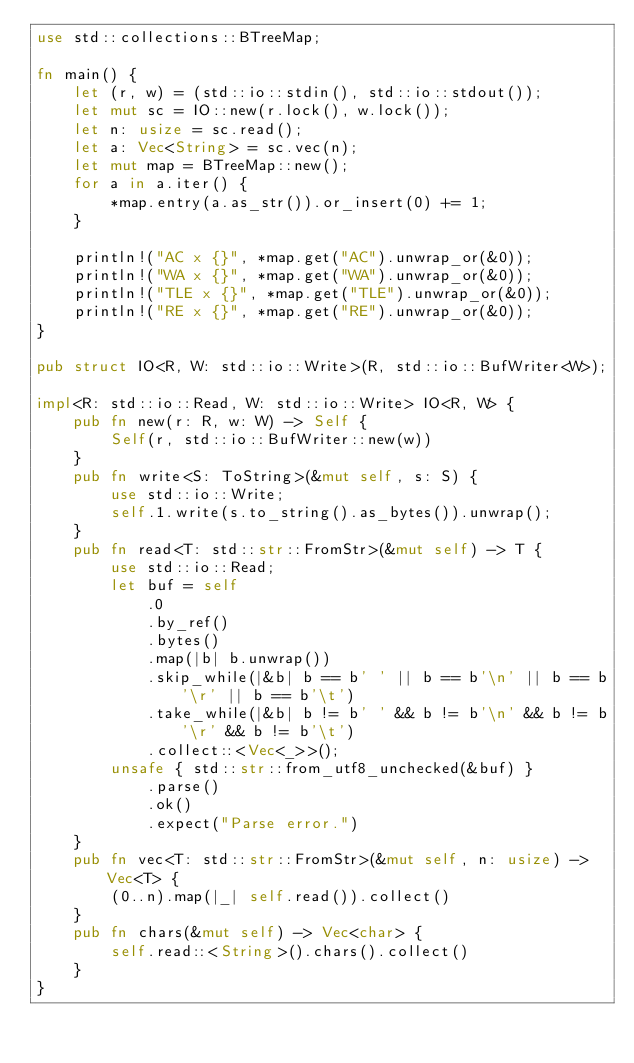<code> <loc_0><loc_0><loc_500><loc_500><_Rust_>use std::collections::BTreeMap;

fn main() {
    let (r, w) = (std::io::stdin(), std::io::stdout());
    let mut sc = IO::new(r.lock(), w.lock());
    let n: usize = sc.read();
    let a: Vec<String> = sc.vec(n);
    let mut map = BTreeMap::new();
    for a in a.iter() {
        *map.entry(a.as_str()).or_insert(0) += 1;
    }

    println!("AC x {}", *map.get("AC").unwrap_or(&0));
    println!("WA x {}", *map.get("WA").unwrap_or(&0));
    println!("TLE x {}", *map.get("TLE").unwrap_or(&0));
    println!("RE x {}", *map.get("RE").unwrap_or(&0));
}

pub struct IO<R, W: std::io::Write>(R, std::io::BufWriter<W>);

impl<R: std::io::Read, W: std::io::Write> IO<R, W> {
    pub fn new(r: R, w: W) -> Self {
        Self(r, std::io::BufWriter::new(w))
    }
    pub fn write<S: ToString>(&mut self, s: S) {
        use std::io::Write;
        self.1.write(s.to_string().as_bytes()).unwrap();
    }
    pub fn read<T: std::str::FromStr>(&mut self) -> T {
        use std::io::Read;
        let buf = self
            .0
            .by_ref()
            .bytes()
            .map(|b| b.unwrap())
            .skip_while(|&b| b == b' ' || b == b'\n' || b == b'\r' || b == b'\t')
            .take_while(|&b| b != b' ' && b != b'\n' && b != b'\r' && b != b'\t')
            .collect::<Vec<_>>();
        unsafe { std::str::from_utf8_unchecked(&buf) }
            .parse()
            .ok()
            .expect("Parse error.")
    }
    pub fn vec<T: std::str::FromStr>(&mut self, n: usize) -> Vec<T> {
        (0..n).map(|_| self.read()).collect()
    }
    pub fn chars(&mut self) -> Vec<char> {
        self.read::<String>().chars().collect()
    }
}
</code> 